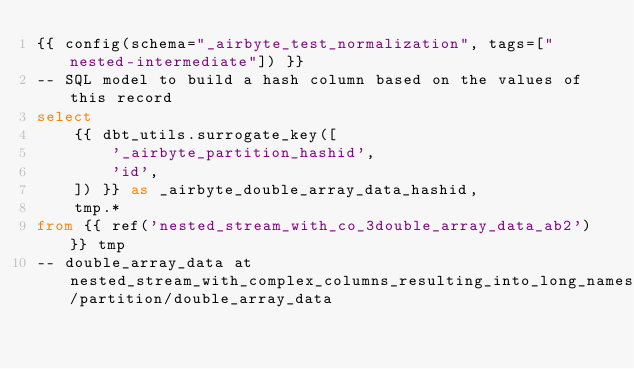<code> <loc_0><loc_0><loc_500><loc_500><_SQL_>{{ config(schema="_airbyte_test_normalization", tags=["nested-intermediate"]) }}
-- SQL model to build a hash column based on the values of this record
select
    {{ dbt_utils.surrogate_key([
        '_airbyte_partition_hashid',
        'id',
    ]) }} as _airbyte_double_array_data_hashid,
    tmp.*
from {{ ref('nested_stream_with_co_3double_array_data_ab2') }} tmp
-- double_array_data at nested_stream_with_complex_columns_resulting_into_long_names/partition/double_array_data

</code> 